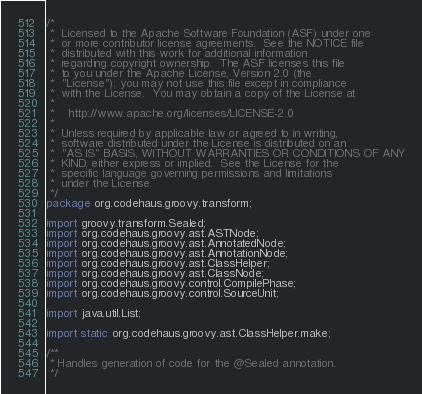<code> <loc_0><loc_0><loc_500><loc_500><_Java_>/*
 *  Licensed to the Apache Software Foundation (ASF) under one
 *  or more contributor license agreements.  See the NOTICE file
 *  distributed with this work for additional information
 *  regarding copyright ownership.  The ASF licenses this file
 *  to you under the Apache License, Version 2.0 (the
 *  "License"); you may not use this file except in compliance
 *  with the License.  You may obtain a copy of the License at
 *
 *    http://www.apache.org/licenses/LICENSE-2.0
 *
 *  Unless required by applicable law or agreed to in writing,
 *  software distributed under the License is distributed on an
 *  "AS IS" BASIS, WITHOUT WARRANTIES OR CONDITIONS OF ANY
 *  KIND, either express or implied.  See the License for the
 *  specific language governing permissions and limitations
 *  under the License.
 */
package org.codehaus.groovy.transform;

import groovy.transform.Sealed;
import org.codehaus.groovy.ast.ASTNode;
import org.codehaus.groovy.ast.AnnotatedNode;
import org.codehaus.groovy.ast.AnnotationNode;
import org.codehaus.groovy.ast.ClassHelper;
import org.codehaus.groovy.ast.ClassNode;
import org.codehaus.groovy.control.CompilePhase;
import org.codehaus.groovy.control.SourceUnit;

import java.util.List;

import static org.codehaus.groovy.ast.ClassHelper.make;

/**
 * Handles generation of code for the @Sealed annotation.
 */</code> 